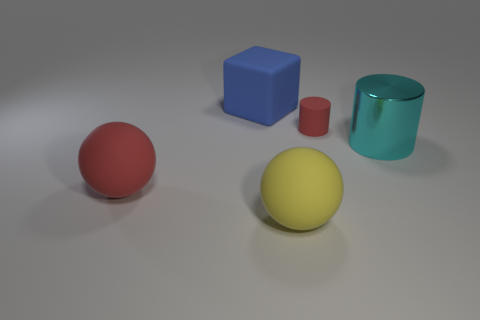How many other objects are the same material as the yellow object?
Give a very brief answer. 3. Is the number of matte cylinders that are behind the large blue matte cube the same as the number of small metallic spheres?
Ensure brevity in your answer.  Yes. Does the yellow matte sphere have the same size as the red object that is to the left of the yellow matte thing?
Your answer should be compact. Yes. There is a red thing that is in front of the small cylinder; what is its shape?
Give a very brief answer. Sphere. Is there anything else that is the same shape as the blue thing?
Offer a terse response. No. Are there any brown rubber cylinders?
Your answer should be very brief. No. Does the blue rubber cube that is to the left of the yellow object have the same size as the red rubber thing that is right of the blue block?
Your answer should be compact. No. There is a large thing that is both to the left of the big yellow thing and in front of the small red matte thing; what is its material?
Offer a terse response. Rubber. There is a cyan metallic cylinder; what number of large matte balls are on the right side of it?
Give a very brief answer. 0. Is there anything else that has the same size as the red cylinder?
Provide a short and direct response. No. 